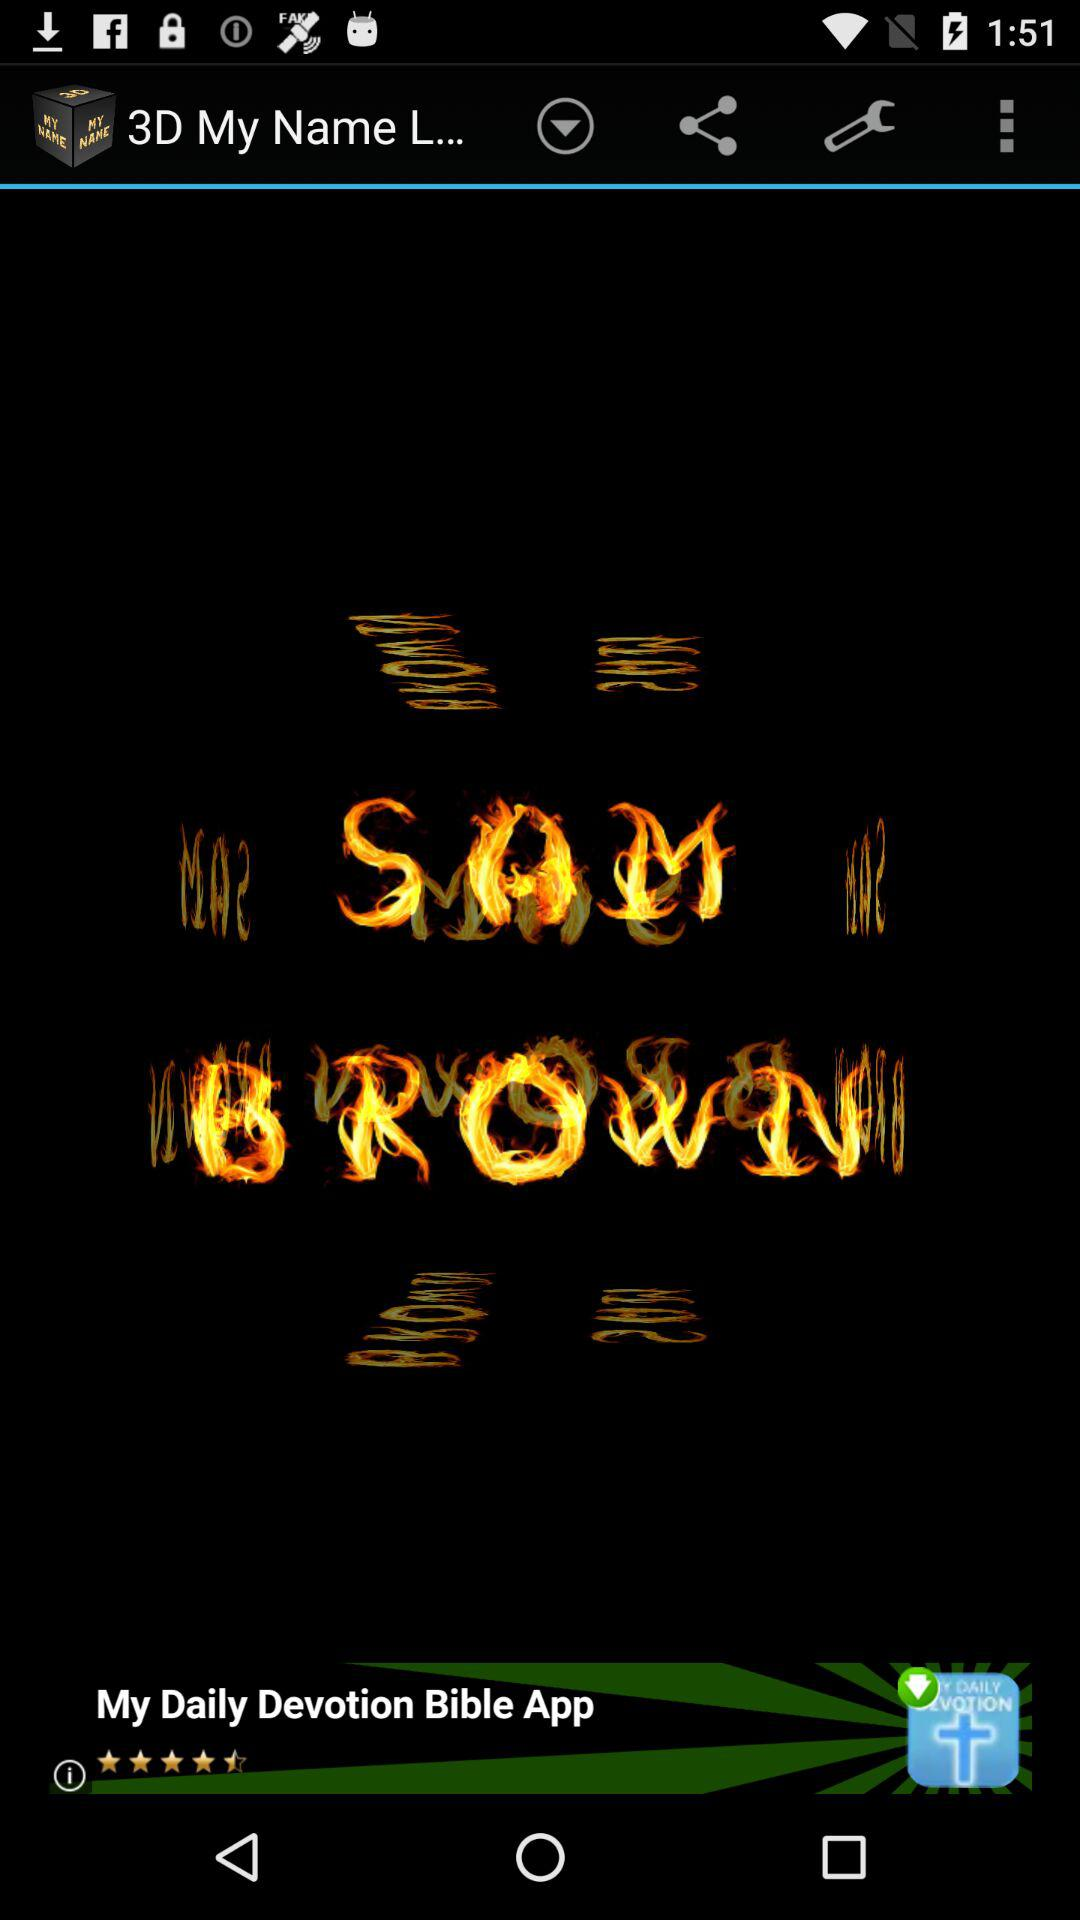What is the application name? The application name is "3D My Name L...". 